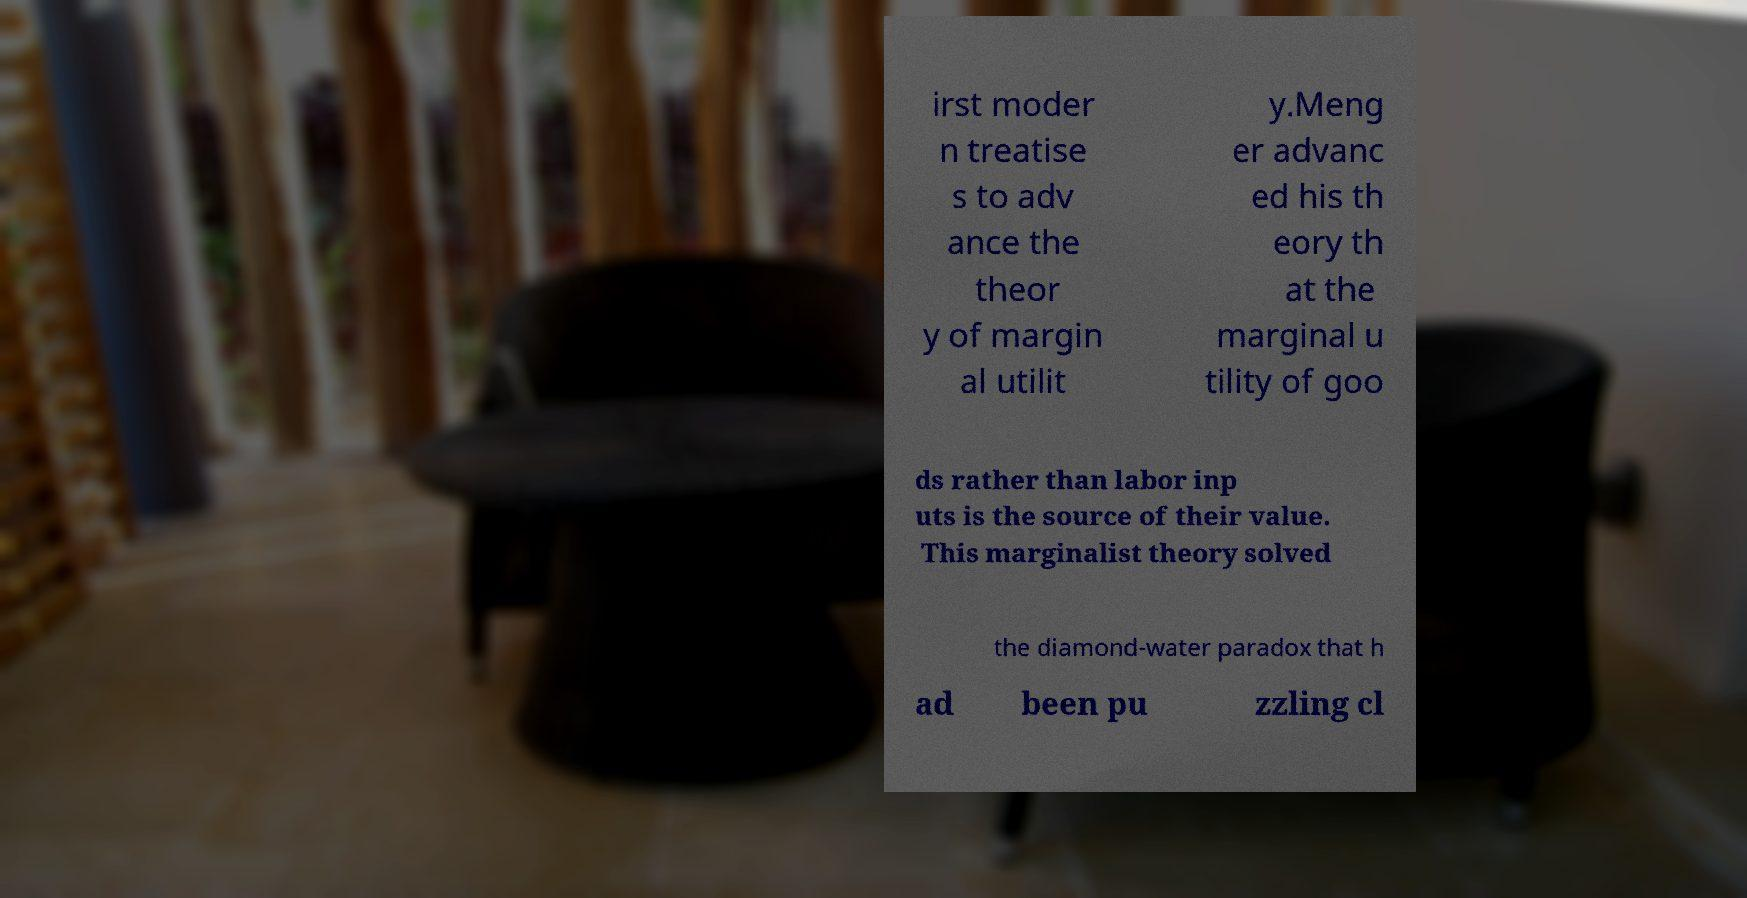Please read and relay the text visible in this image. What does it say? irst moder n treatise s to adv ance the theor y of margin al utilit y.Meng er advanc ed his th eory th at the marginal u tility of goo ds rather than labor inp uts is the source of their value. This marginalist theory solved the diamond-water paradox that h ad been pu zzling cl 